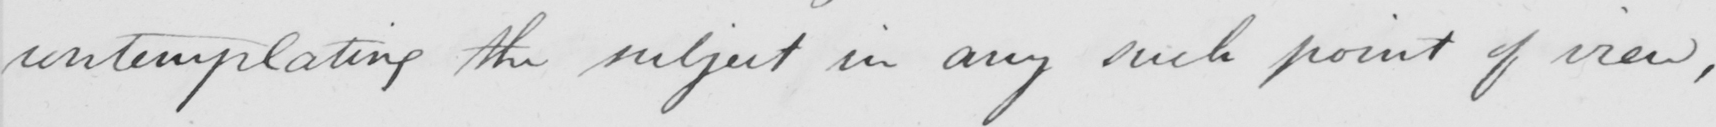What does this handwritten line say? comtemplating the subject in any such point of view 